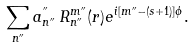Convert formula to latex. <formula><loc_0><loc_0><loc_500><loc_500>\sum _ { n { ^ { \prime \prime } } } a ^ { ^ { \prime \prime } } _ { n { ^ { \prime \prime } } } \, R _ { n { ^ { \prime \prime } } } ^ { m { ^ { \prime \prime } } } ( r ) e ^ { i [ m { ^ { \prime \prime } } - ( s + 1 ) ] \phi } .</formula> 